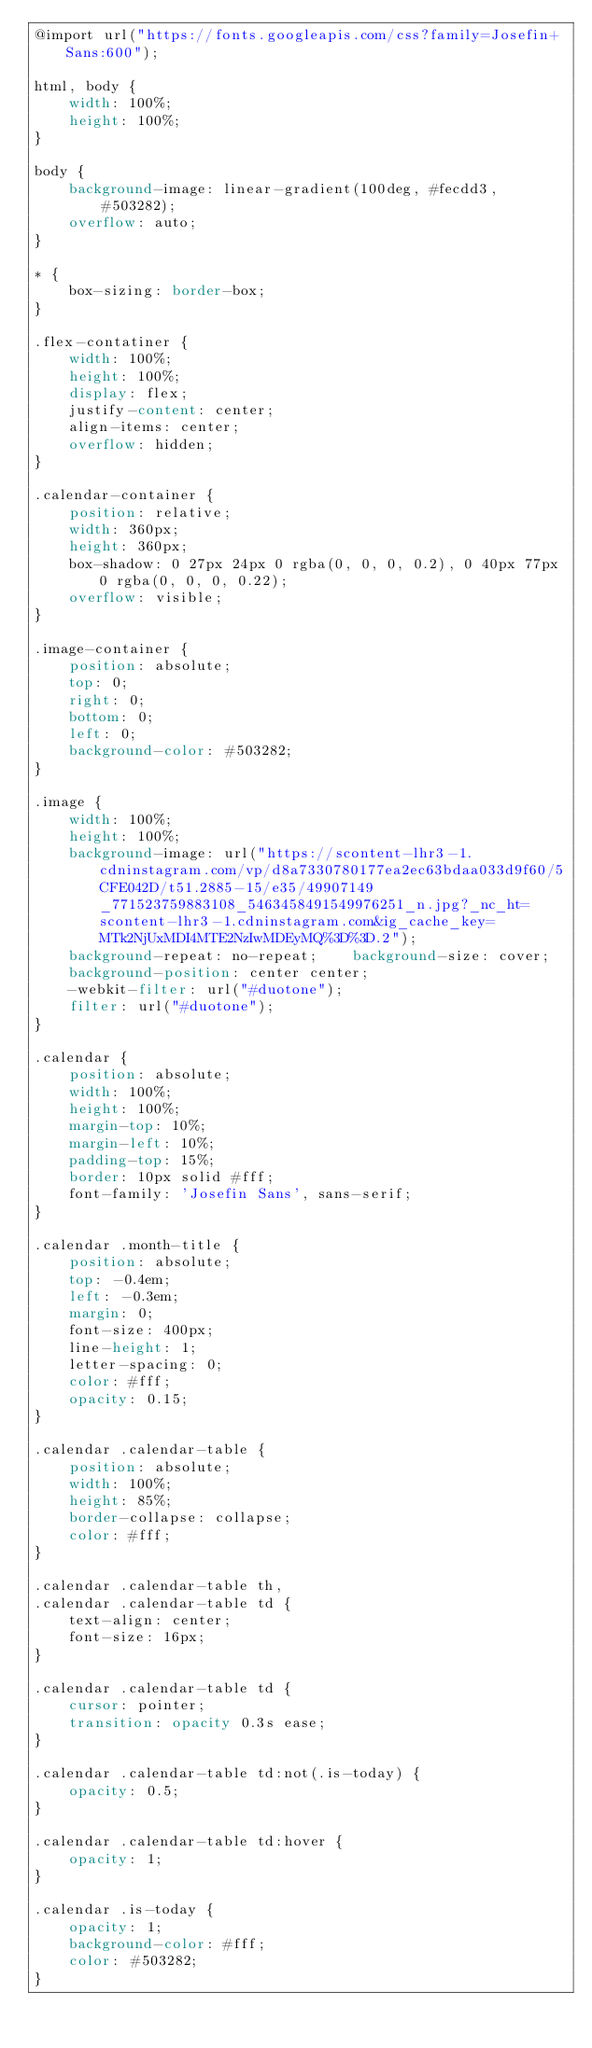Convert code to text. <code><loc_0><loc_0><loc_500><loc_500><_CSS_>@import url("https://fonts.googleapis.com/css?family=Josefin+Sans:600");

html, body {
    width: 100%;
    height: 100%;
}

body {
    background-image: linear-gradient(100deg, #fecdd3, #503282);
    overflow: auto;
}

* {
    box-sizing: border-box;
}

.flex-contatiner {
    width: 100%;
    height: 100%;
    display: flex;
    justify-content: center;
    align-items: center;
    overflow: hidden;
}

.calendar-container {
    position: relative;
    width: 360px;
    height: 360px;
    box-shadow: 0 27px 24px 0 rgba(0, 0, 0, 0.2), 0 40px 77px 0 rgba(0, 0, 0, 0.22);
    overflow: visible;
}

.image-container {
    position: absolute;
    top: 0;
    right: 0;
    bottom: 0;
    left: 0;
    background-color: #503282;
}

.image {
    width: 100%;
    height: 100%;
    background-image: url("https://scontent-lhr3-1.cdninstagram.com/vp/d8a7330780177ea2ec63bdaa033d9f60/5CFE042D/t51.2885-15/e35/49907149_771523759883108_5463458491549976251_n.jpg?_nc_ht=scontent-lhr3-1.cdninstagram.com&ig_cache_key=MTk2NjUxMDI4MTE2NzIwMDEyMQ%3D%3D.2");
    background-repeat: no-repeat;    background-size: cover;
    background-position: center center;
    -webkit-filter: url("#duotone");
    filter: url("#duotone");
}

.calendar {
    position: absolute;
    width: 100%;
    height: 100%;
    margin-top: 10%;
    margin-left: 10%;
    padding-top: 15%;
    border: 10px solid #fff;
    font-family: 'Josefin Sans', sans-serif;
}

.calendar .month-title {
    position: absolute;
    top: -0.4em;
    left: -0.3em;
    margin: 0;
    font-size: 400px;
    line-height: 1;
    letter-spacing: 0;
    color: #fff;
    opacity: 0.15;
}

.calendar .calendar-table {
    position: absolute;
    width: 100%;
    height: 85%;
    border-collapse: collapse;
    color: #fff;
}

.calendar .calendar-table th,
.calendar .calendar-table td {
    text-align: center;
    font-size: 16px;
}

.calendar .calendar-table td {
    cursor: pointer;
    transition: opacity 0.3s ease;
}

.calendar .calendar-table td:not(.is-today) {
    opacity: 0.5;
}

.calendar .calendar-table td:hover {
    opacity: 1;
}

.calendar .is-today {
    opacity: 1;
    background-color: #fff;
    color: #503282;
}</code> 